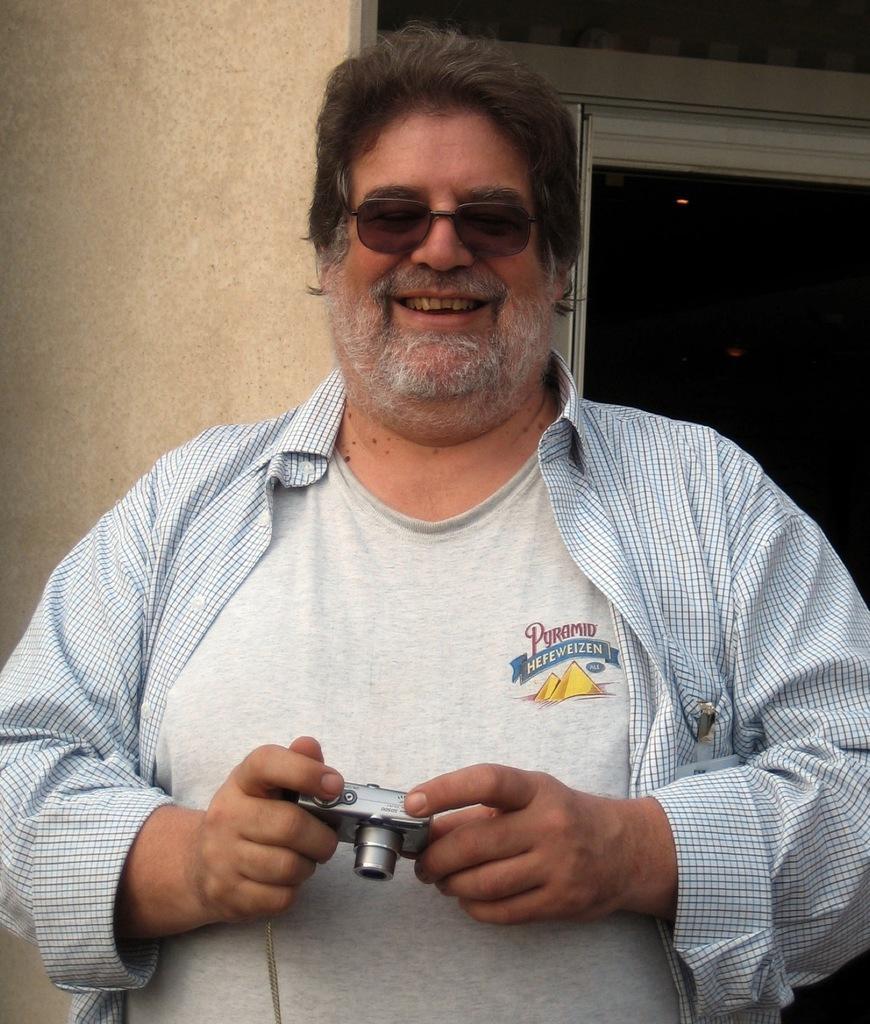Please provide a concise description of this image. As we can see in the image there is wall, window, a woman wearing white color t shirt and holding camera. 